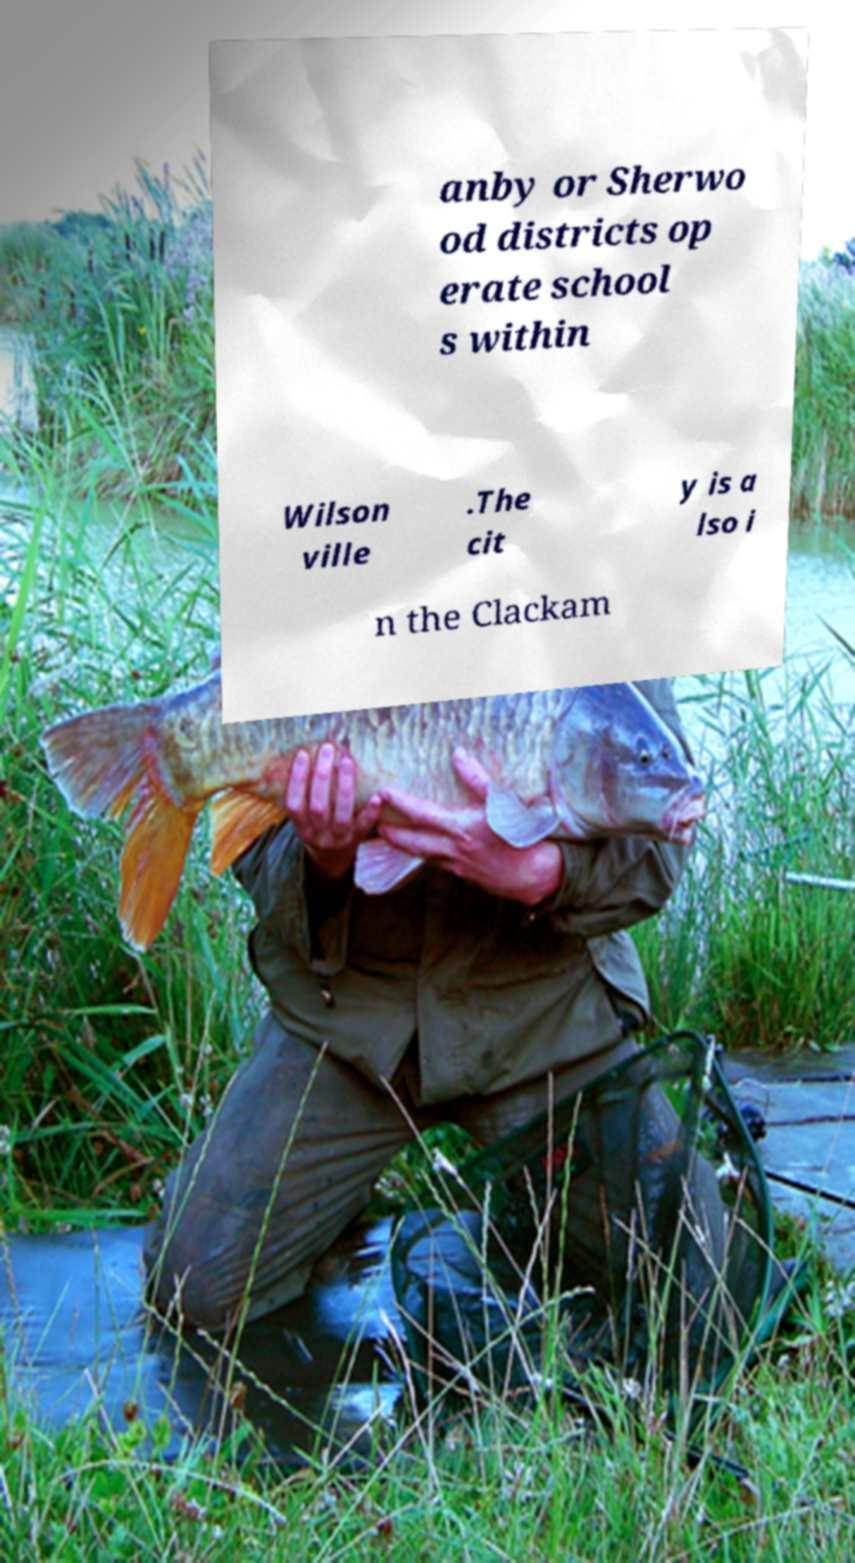Could you assist in decoding the text presented in this image and type it out clearly? anby or Sherwo od districts op erate school s within Wilson ville .The cit y is a lso i n the Clackam 